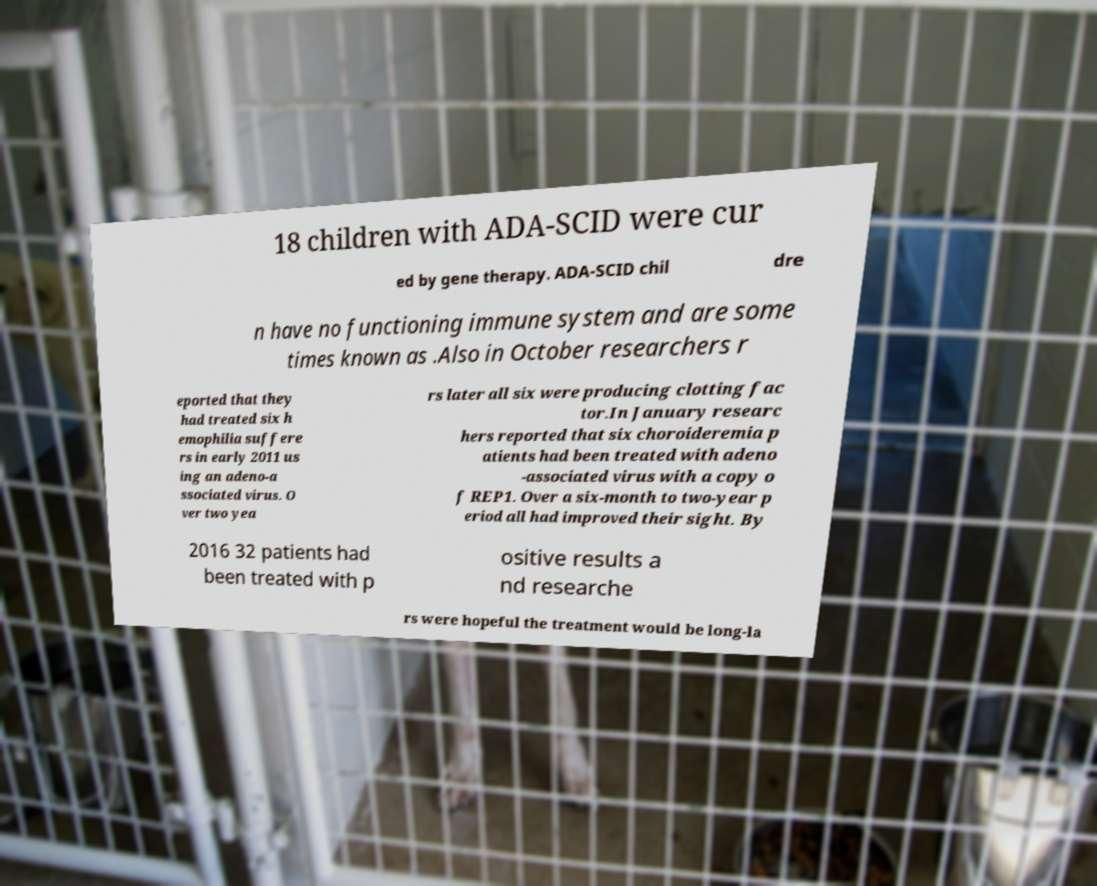Please read and relay the text visible in this image. What does it say? 18 children with ADA-SCID were cur ed by gene therapy. ADA-SCID chil dre n have no functioning immune system and are some times known as .Also in October researchers r eported that they had treated six h emophilia suffere rs in early 2011 us ing an adeno-a ssociated virus. O ver two yea rs later all six were producing clotting fac tor.In January researc hers reported that six choroideremia p atients had been treated with adeno -associated virus with a copy o f REP1. Over a six-month to two-year p eriod all had improved their sight. By 2016 32 patients had been treated with p ositive results a nd researche rs were hopeful the treatment would be long-la 